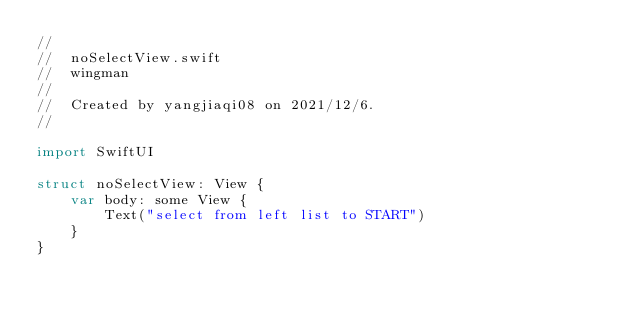<code> <loc_0><loc_0><loc_500><loc_500><_Swift_>//
//  noSelectView.swift
//  wingman
//
//  Created by yangjiaqi08 on 2021/12/6.
//

import SwiftUI

struct noSelectView: View {
    var body: some View {
        Text("select from left list to START")
    }
}
</code> 